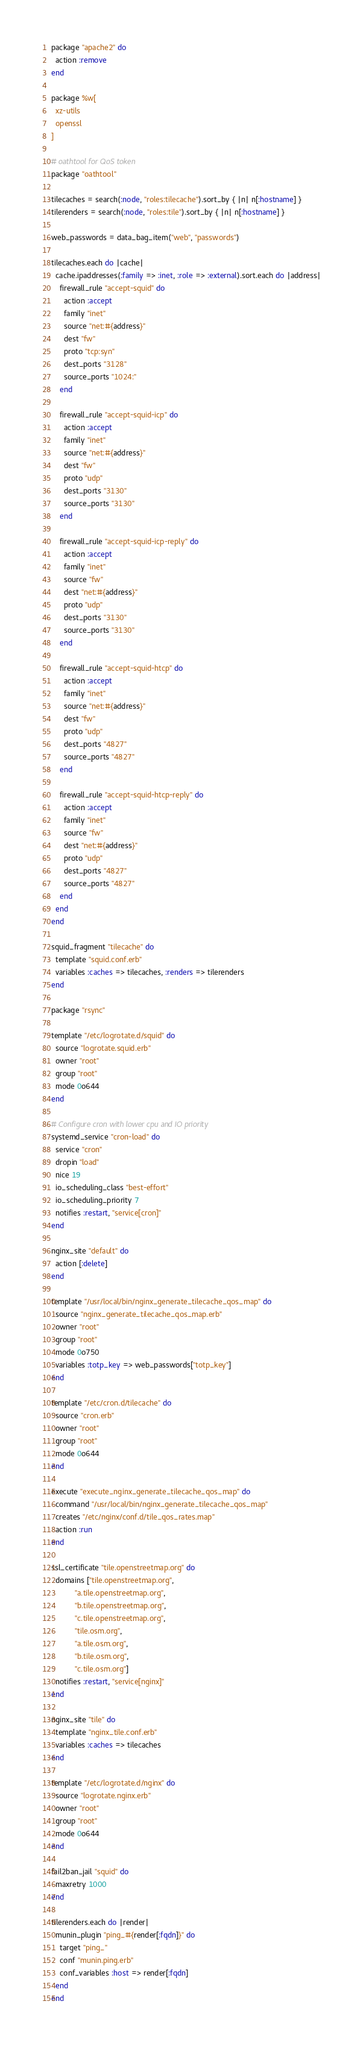Convert code to text. <code><loc_0><loc_0><loc_500><loc_500><_Ruby_>
package "apache2" do
  action :remove
end

package %w[
  xz-utils
  openssl
]

# oathtool for QoS token
package "oathtool"

tilecaches = search(:node, "roles:tilecache").sort_by { |n| n[:hostname] }
tilerenders = search(:node, "roles:tile").sort_by { |n| n[:hostname] }

web_passwords = data_bag_item("web", "passwords")

tilecaches.each do |cache|
  cache.ipaddresses(:family => :inet, :role => :external).sort.each do |address|
    firewall_rule "accept-squid" do
      action :accept
      family "inet"
      source "net:#{address}"
      dest "fw"
      proto "tcp:syn"
      dest_ports "3128"
      source_ports "1024:"
    end

    firewall_rule "accept-squid-icp" do
      action :accept
      family "inet"
      source "net:#{address}"
      dest "fw"
      proto "udp"
      dest_ports "3130"
      source_ports "3130"
    end

    firewall_rule "accept-squid-icp-reply" do
      action :accept
      family "inet"
      source "fw"
      dest "net:#{address}"
      proto "udp"
      dest_ports "3130"
      source_ports "3130"
    end

    firewall_rule "accept-squid-htcp" do
      action :accept
      family "inet"
      source "net:#{address}"
      dest "fw"
      proto "udp"
      dest_ports "4827"
      source_ports "4827"
    end

    firewall_rule "accept-squid-htcp-reply" do
      action :accept
      family "inet"
      source "fw"
      dest "net:#{address}"
      proto "udp"
      dest_ports "4827"
      source_ports "4827"
    end
  end
end

squid_fragment "tilecache" do
  template "squid.conf.erb"
  variables :caches => tilecaches, :renders => tilerenders
end

package "rsync"

template "/etc/logrotate.d/squid" do
  source "logrotate.squid.erb"
  owner "root"
  group "root"
  mode 0o644
end

# Configure cron with lower cpu and IO priority
systemd_service "cron-load" do
  service "cron"
  dropin "load"
  nice 19
  io_scheduling_class "best-effort"
  io_scheduling_priority 7
  notifies :restart, "service[cron]"
end

nginx_site "default" do
  action [:delete]
end

template "/usr/local/bin/nginx_generate_tilecache_qos_map" do
  source "nginx_generate_tilecache_qos_map.erb"
  owner "root"
  group "root"
  mode 0o750
  variables :totp_key => web_passwords["totp_key"]
end

template "/etc/cron.d/tilecache" do
  source "cron.erb"
  owner "root"
  group "root"
  mode 0o644
end

execute "execute_nginx_generate_tilecache_qos_map" do
  command "/usr/local/bin/nginx_generate_tilecache_qos_map"
  creates "/etc/nginx/conf.d/tile_qos_rates.map"
  action :run
end

ssl_certificate "tile.openstreetmap.org" do
  domains ["tile.openstreetmap.org",
           "a.tile.openstreetmap.org",
           "b.tile.openstreetmap.org",
           "c.tile.openstreetmap.org",
           "tile.osm.org",
           "a.tile.osm.org",
           "b.tile.osm.org",
           "c.tile.osm.org"]
  notifies :restart, "service[nginx]"
end

nginx_site "tile" do
  template "nginx_tile.conf.erb"
  variables :caches => tilecaches
end

template "/etc/logrotate.d/nginx" do
  source "logrotate.nginx.erb"
  owner "root"
  group "root"
  mode 0o644
end

fail2ban_jail "squid" do
  maxretry 1000
end

tilerenders.each do |render|
  munin_plugin "ping_#{render[:fqdn]}" do
    target "ping_"
    conf "munin.ping.erb"
    conf_variables :host => render[:fqdn]
  end
end
</code> 